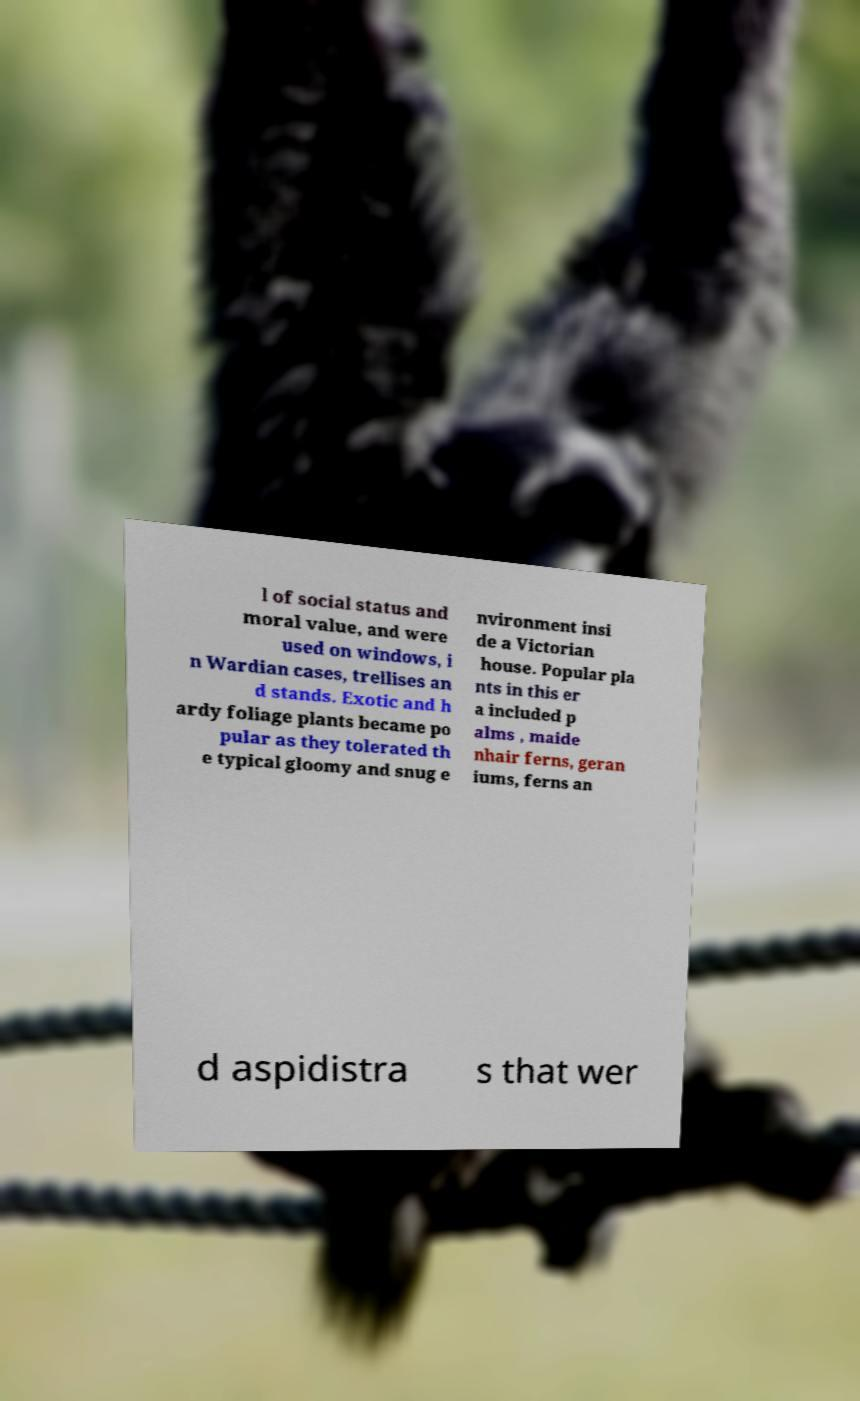There's text embedded in this image that I need extracted. Can you transcribe it verbatim? l of social status and moral value, and were used on windows, i n Wardian cases, trellises an d stands. Exotic and h ardy foliage plants became po pular as they tolerated th e typical gloomy and snug e nvironment insi de a Victorian house. Popular pla nts in this er a included p alms , maide nhair ferns, geran iums, ferns an d aspidistra s that wer 